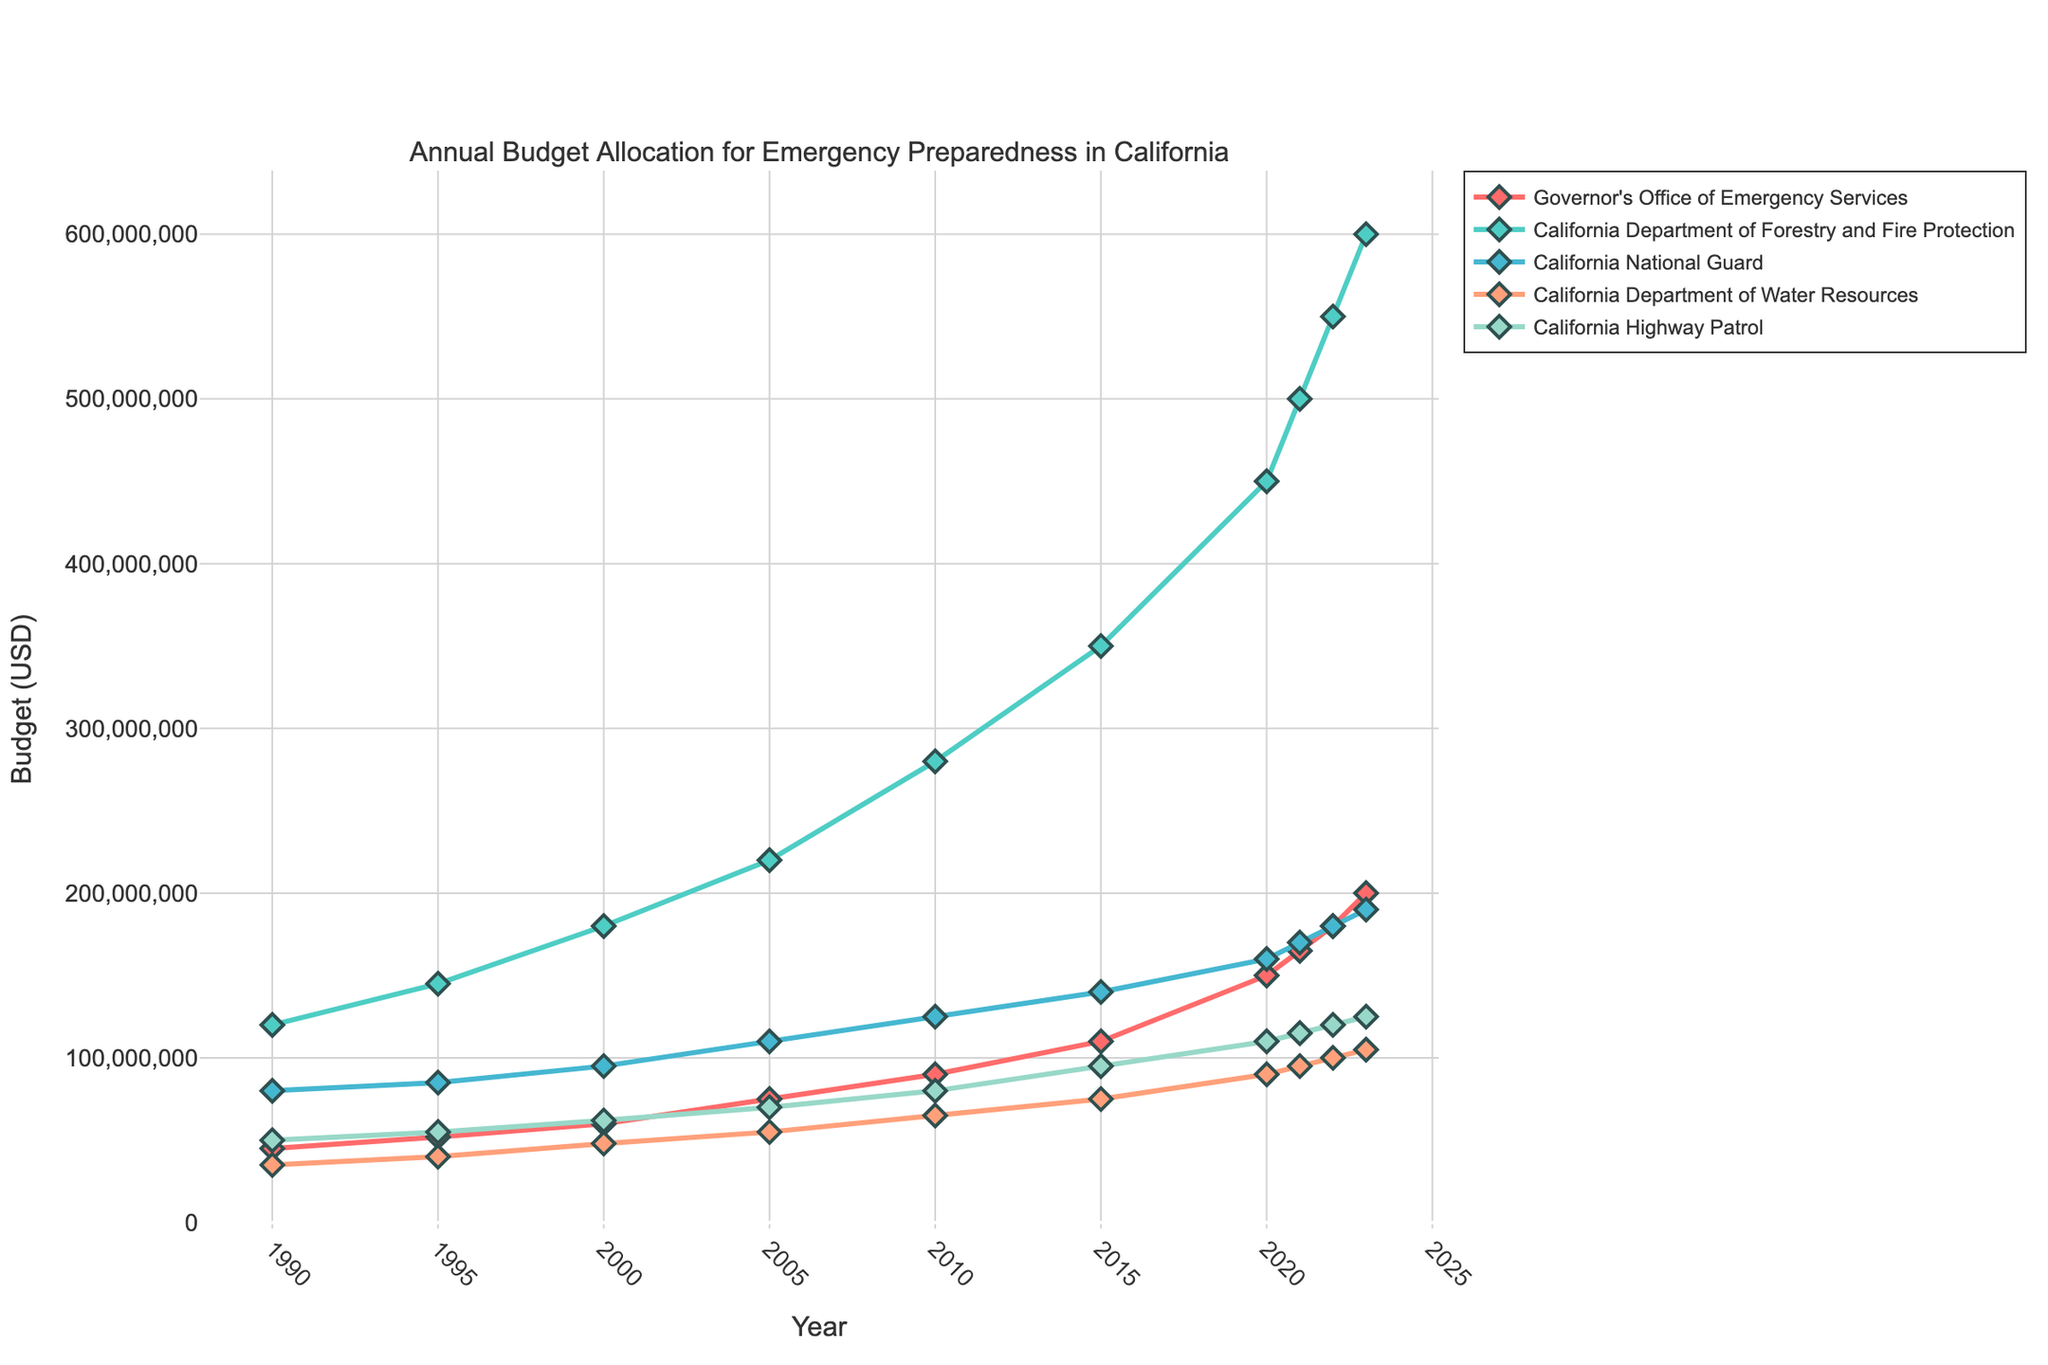what is the total budget allocation for all departments in 2023? To find the total budget allocation in 2023, sum the values for each department: Governor's Office of Emergency Services (200,000,000) + California Department of Forestry and Fire Protection (600,000,000) + California National Guard (190,000,000) + California Department of Water Resources (105,000,000) + California Highway Patrol (125,000,000). Summing these gives 1,220,000,000
Answer: 1,220,000,000 Which department received the highest budget allocation in 2000? Look at the budgets for each department in 2000 and compare them: Governor's Office of Emergency Services (60,000,000), California Department of Forestry and Fire Protection (180,000,000), California National Guard (95,000,000), California Department of Water Resources (48,000,000), and California Highway Patrol (62,000,000). The highest value is for the California Department of Forestry and Fire Protection.
Answer: California Department of Forestry and Fire Protection How much has the budget for the California National Guard increased from 1990 to 2023? Subtract the budget for the California National Guard in 1990 (80,000,000) from the budget in 2023 (190,000,000). The difference is 190,000,000 - 80,000,000 = 110,000,000
Answer: 110,000,000 In which year did the Governor's Office of Emergency Services receive a budget above 100 million USD for the first time? Examine the budget data for the Governor's Office of Emergency Services by year to find when it first exceeds 100 million USD. It first occurred in 2015 with a budget of 110,000,000
Answer: 2015 What is the average budget allocation for the California Department of Water Resources from 1990 to 2023? Sum the budget allocations for the California Department of Water Resources across the years: 35,000,000 + 40,000,000 + 48,000,000 + 55,000,000 + 65,000,000 + 75,000,000 + 90,000,000 + 95,000,000 + 100,000,000 + 105,000,000 = 603,000,000. Divide this sum by the number of years (10): 603,000,000 / 10 = 60,300,000
Answer: 60,300,000 Compare the budget of the California National Guard and the California Department of Water Resources in 2020. Which one had a higher allocation? The budget for the California National Guard in 2020 was 160,000,000, and for the California Department of Water Resources it was 90,000,000. Comparing the two, the California National Guard had a higher allocation
Answer: California National Guard 